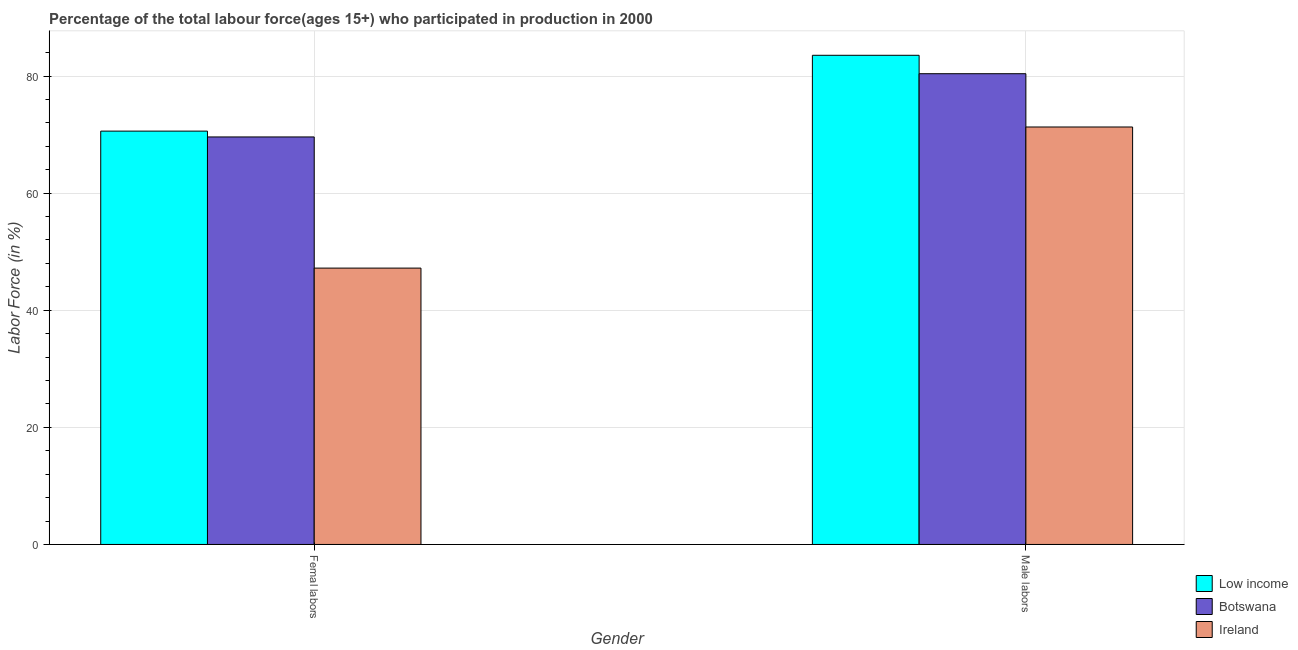How many different coloured bars are there?
Provide a short and direct response. 3. Are the number of bars per tick equal to the number of legend labels?
Give a very brief answer. Yes. Are the number of bars on each tick of the X-axis equal?
Ensure brevity in your answer.  Yes. How many bars are there on the 1st tick from the left?
Your response must be concise. 3. How many bars are there on the 1st tick from the right?
Provide a short and direct response. 3. What is the label of the 2nd group of bars from the left?
Ensure brevity in your answer.  Male labors. What is the percentage of female labor force in Ireland?
Offer a terse response. 47.2. Across all countries, what is the maximum percentage of female labor force?
Offer a terse response. 70.6. Across all countries, what is the minimum percentage of female labor force?
Your response must be concise. 47.2. In which country was the percentage of male labour force minimum?
Offer a very short reply. Ireland. What is the total percentage of female labor force in the graph?
Your answer should be very brief. 187.4. What is the difference between the percentage of female labor force in Ireland and that in Botswana?
Give a very brief answer. -22.4. What is the difference between the percentage of male labour force in Botswana and the percentage of female labor force in Low income?
Make the answer very short. 9.8. What is the average percentage of female labor force per country?
Give a very brief answer. 62.47. What is the difference between the percentage of male labour force and percentage of female labor force in Botswana?
Give a very brief answer. 10.8. What is the ratio of the percentage of female labor force in Low income to that in Botswana?
Offer a very short reply. 1.01. Is the percentage of male labour force in Botswana less than that in Low income?
Offer a terse response. Yes. What does the 1st bar from the left in Male labors represents?
Give a very brief answer. Low income. How many bars are there?
Your answer should be compact. 6. Are all the bars in the graph horizontal?
Your answer should be compact. No. Are the values on the major ticks of Y-axis written in scientific E-notation?
Your response must be concise. No. Does the graph contain any zero values?
Give a very brief answer. No. How many legend labels are there?
Make the answer very short. 3. What is the title of the graph?
Offer a very short reply. Percentage of the total labour force(ages 15+) who participated in production in 2000. What is the Labor Force (in %) in Low income in Femal labors?
Give a very brief answer. 70.6. What is the Labor Force (in %) of Botswana in Femal labors?
Your answer should be compact. 69.6. What is the Labor Force (in %) of Ireland in Femal labors?
Keep it short and to the point. 47.2. What is the Labor Force (in %) in Low income in Male labors?
Your answer should be compact. 83.55. What is the Labor Force (in %) of Botswana in Male labors?
Provide a short and direct response. 80.4. What is the Labor Force (in %) of Ireland in Male labors?
Your response must be concise. 71.3. Across all Gender, what is the maximum Labor Force (in %) in Low income?
Your answer should be compact. 83.55. Across all Gender, what is the maximum Labor Force (in %) of Botswana?
Provide a short and direct response. 80.4. Across all Gender, what is the maximum Labor Force (in %) in Ireland?
Offer a very short reply. 71.3. Across all Gender, what is the minimum Labor Force (in %) in Low income?
Ensure brevity in your answer.  70.6. Across all Gender, what is the minimum Labor Force (in %) in Botswana?
Your answer should be compact. 69.6. Across all Gender, what is the minimum Labor Force (in %) of Ireland?
Your answer should be compact. 47.2. What is the total Labor Force (in %) of Low income in the graph?
Ensure brevity in your answer.  154.14. What is the total Labor Force (in %) in Botswana in the graph?
Provide a short and direct response. 150. What is the total Labor Force (in %) of Ireland in the graph?
Your answer should be compact. 118.5. What is the difference between the Labor Force (in %) in Low income in Femal labors and that in Male labors?
Keep it short and to the point. -12.95. What is the difference between the Labor Force (in %) of Botswana in Femal labors and that in Male labors?
Keep it short and to the point. -10.8. What is the difference between the Labor Force (in %) of Ireland in Femal labors and that in Male labors?
Offer a very short reply. -24.1. What is the difference between the Labor Force (in %) of Low income in Femal labors and the Labor Force (in %) of Botswana in Male labors?
Keep it short and to the point. -9.8. What is the difference between the Labor Force (in %) in Low income in Femal labors and the Labor Force (in %) in Ireland in Male labors?
Ensure brevity in your answer.  -0.7. What is the difference between the Labor Force (in %) of Botswana in Femal labors and the Labor Force (in %) of Ireland in Male labors?
Keep it short and to the point. -1.7. What is the average Labor Force (in %) in Low income per Gender?
Make the answer very short. 77.07. What is the average Labor Force (in %) of Ireland per Gender?
Make the answer very short. 59.25. What is the difference between the Labor Force (in %) in Low income and Labor Force (in %) in Ireland in Femal labors?
Your answer should be very brief. 23.4. What is the difference between the Labor Force (in %) of Botswana and Labor Force (in %) of Ireland in Femal labors?
Your answer should be compact. 22.4. What is the difference between the Labor Force (in %) of Low income and Labor Force (in %) of Botswana in Male labors?
Make the answer very short. 3.15. What is the difference between the Labor Force (in %) of Low income and Labor Force (in %) of Ireland in Male labors?
Offer a very short reply. 12.25. What is the difference between the Labor Force (in %) of Botswana and Labor Force (in %) of Ireland in Male labors?
Provide a succinct answer. 9.1. What is the ratio of the Labor Force (in %) of Low income in Femal labors to that in Male labors?
Keep it short and to the point. 0.84. What is the ratio of the Labor Force (in %) of Botswana in Femal labors to that in Male labors?
Keep it short and to the point. 0.87. What is the ratio of the Labor Force (in %) in Ireland in Femal labors to that in Male labors?
Make the answer very short. 0.66. What is the difference between the highest and the second highest Labor Force (in %) in Low income?
Offer a terse response. 12.95. What is the difference between the highest and the second highest Labor Force (in %) in Ireland?
Ensure brevity in your answer.  24.1. What is the difference between the highest and the lowest Labor Force (in %) in Low income?
Make the answer very short. 12.95. What is the difference between the highest and the lowest Labor Force (in %) of Ireland?
Your answer should be very brief. 24.1. 